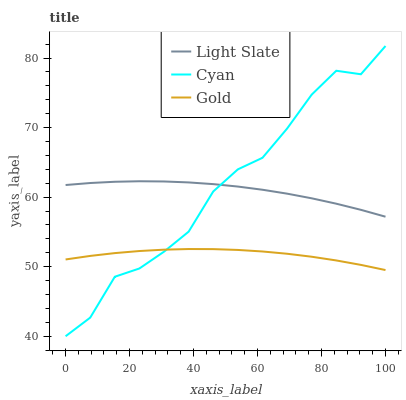Does Gold have the minimum area under the curve?
Answer yes or no. Yes. Does Cyan have the maximum area under the curve?
Answer yes or no. Yes. Does Cyan have the minimum area under the curve?
Answer yes or no. No. Does Gold have the maximum area under the curve?
Answer yes or no. No. Is Gold the smoothest?
Answer yes or no. Yes. Is Cyan the roughest?
Answer yes or no. Yes. Is Cyan the smoothest?
Answer yes or no. No. Is Gold the roughest?
Answer yes or no. No. Does Cyan have the lowest value?
Answer yes or no. Yes. Does Gold have the lowest value?
Answer yes or no. No. Does Cyan have the highest value?
Answer yes or no. Yes. Does Gold have the highest value?
Answer yes or no. No. Is Gold less than Light Slate?
Answer yes or no. Yes. Is Light Slate greater than Gold?
Answer yes or no. Yes. Does Cyan intersect Light Slate?
Answer yes or no. Yes. Is Cyan less than Light Slate?
Answer yes or no. No. Is Cyan greater than Light Slate?
Answer yes or no. No. Does Gold intersect Light Slate?
Answer yes or no. No. 